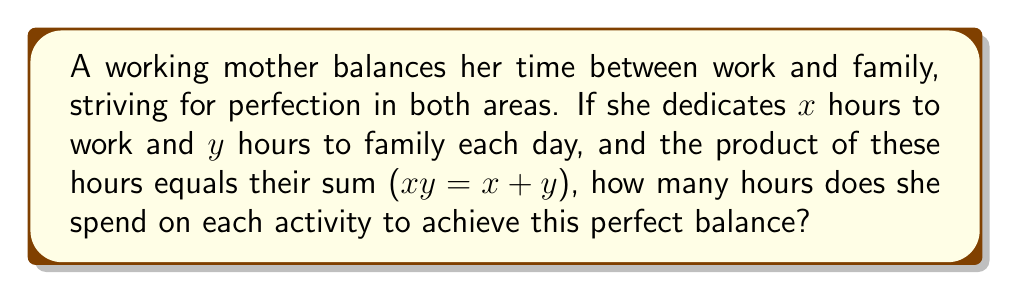Teach me how to tackle this problem. Let's approach this step-by-step:

1) We're given that $xy = x + y$. This equation resembles the definition of perfect numbers, where a number is perfect if it equals the sum of its proper divisors.

2) To solve this, let's rearrange the equation:
   $xy - x - y = 0$

3) Factor out $x$:
   $x(y - 1) - y = 0$

4) Add $y$ to both sides:
   $x(y - 1) = y$

5) Divide both sides by $(y - 1)$:
   $x = \frac{y}{y-1}$

6) This can be rewritten as:
   $x = 1 + \frac{1}{y-1}$

7) For $x$ to be a whole number, $y-1$ must be 1, 2, or 3.

8) If $y-1 = 1$, then $y = 2$ and $x = 2$
   If $y-1 = 2$, then $y = 3$ and $x = 1.5$ (not a whole number)
   If $y-1 = 3$, then $y = 4$ and $x = 1.33$ (not a whole number)

9) Therefore, the only integer solution is $x = 2$ and $y = 2$

This solution reflects a perfect balance where the mother spends equal time on work and family.
Answer: 2 hours on work, 2 hours on family 